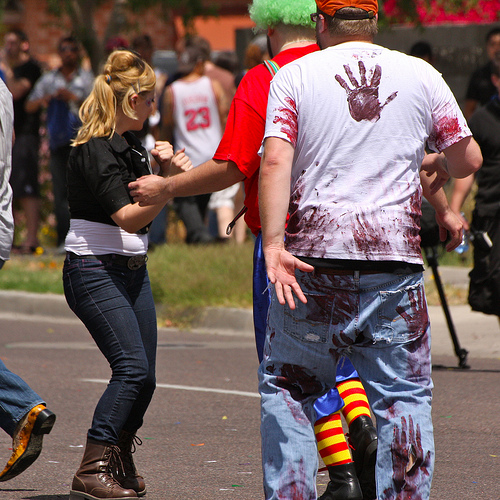<image>
Is the man to the right of the man? Yes. From this viewpoint, the man is positioned to the right side relative to the man. 